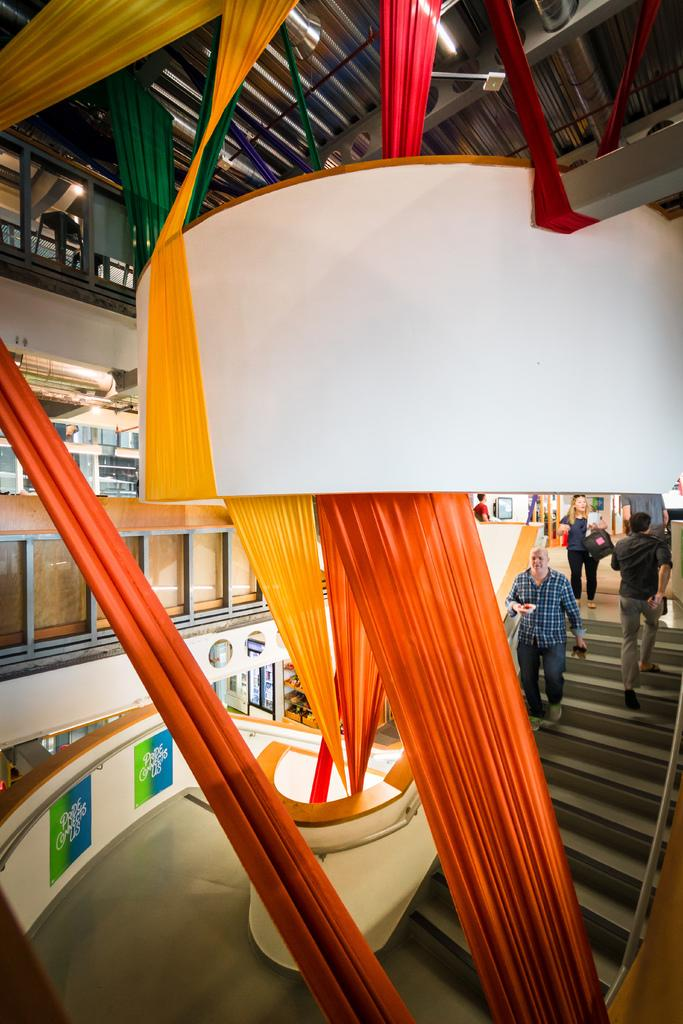Where was the image taken? The image is taken inside a building. What can be seen in the image besides the building's interior? There are clothes of different colors in the image. What architectural feature is present in the image? There is a staircase in the image. Are there any people in the image? Yes, there are people on the staircase. What can be seen on the roof in the image? There are lights on the roof in the image. What type of wing is visible on the sweater in the image? There is no sweater present in the image, and therefore no wing to be seen on it. 